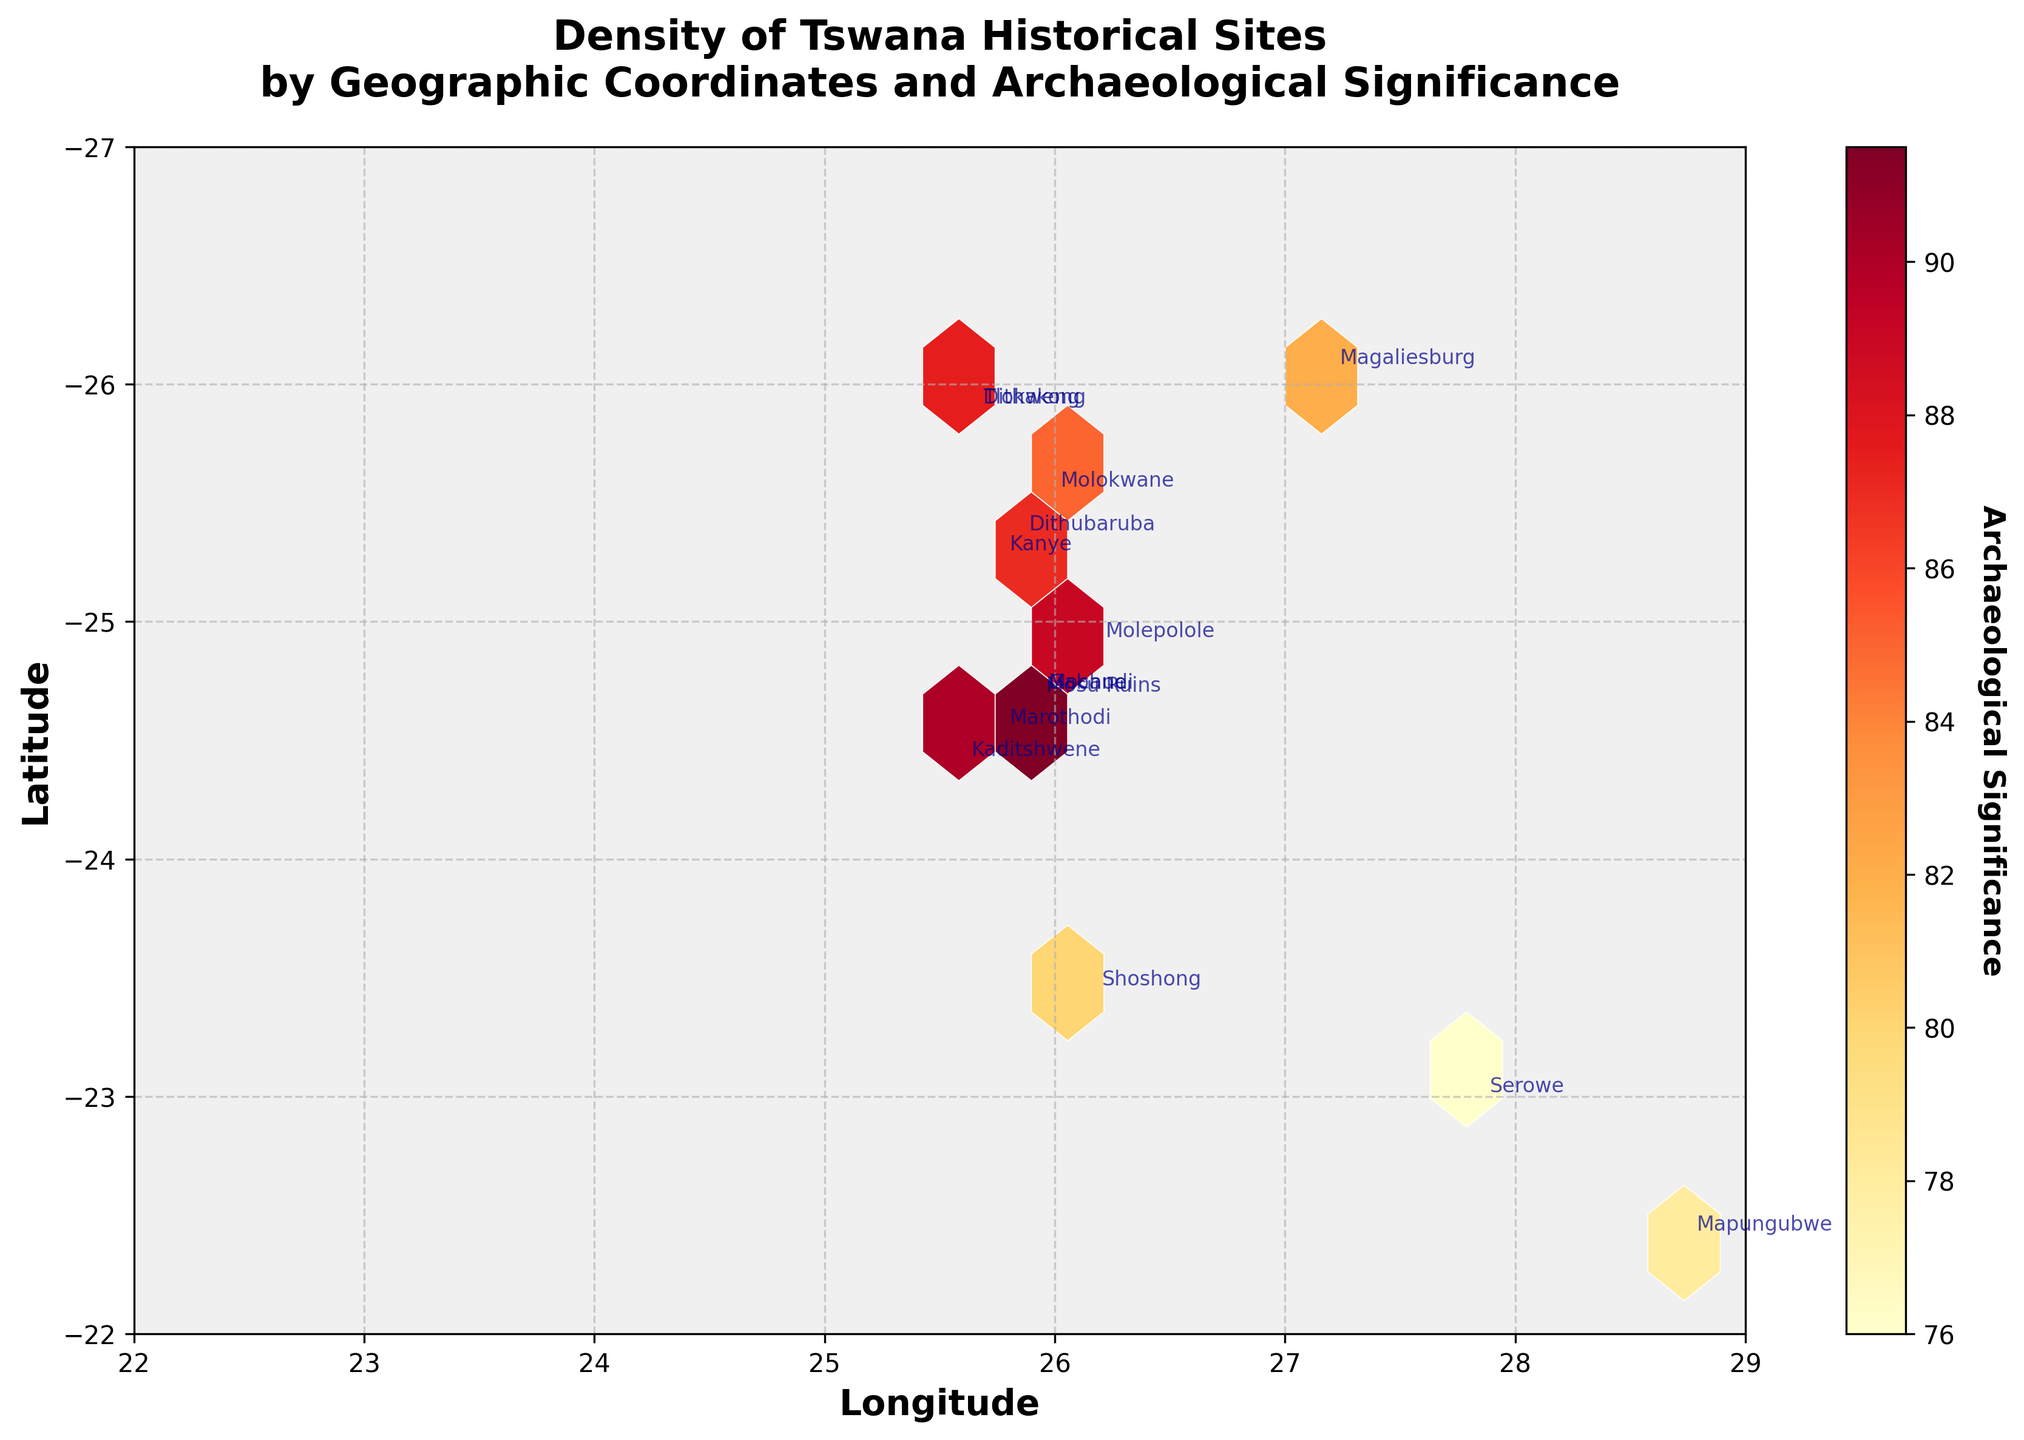Which site has the highest archaeological significance? The bar in the color legend or the specific annotations close to the hexagonal bins can help identify that Mosu Ruins has the highest archaeological significance with a value of 95.
Answer: Mosu Ruins What is the range of longitude covered by the sites? The x-axis of the hexbin plot displays the longitude range. The smallest longitude value is 22 and the largest is approximately 29.
Answer: 7 How densely clustered are the sites around latitude -24.6 and longitude 25.9? This can be seen by observing how many hexagons cluster near the coordinates (-24.6, 25.9). The density of sites in this area is high, indicated by dark color.
Answer: Very dense Which site is closest to the longitude of 25.7500? By looking at the hexagons and annotations around longitude 25.7500, we can find Marothodi and Kanye. The dot for Marothodi is more closely aligned with the specified longitude.
Answer: Marothodi Are sites more densely clustered around a particular latitude? The figure shows that there is a higher density of sites clustered around latitude -24.7 to -25 due to the higher intensity of colored hexagons around this latitude range.
Answer: Around -24.7 to -25 Which site is located furthest south? Observing the placement of site names in the hexbin plot, we can see that Magaliesburg is the furthest south.
Answer: Magaliesburg What is the median archaeological significance of the sites? First, list out the archaeological significance values: [76, 78, 80, 82, 83, 85, 86, 87, 88, 89, 90, 91, 92, 93, 95]. Since there are 15 sites, the median is the 8th value in this ordered list, which is 86.
Answer: 86 How does the significance of Marothodi compare to that of Tlokweng? By looking at their annotated values, Marothodi has an archaeological significance of 92, and Tlokweng has 87. Marothodi's archaeological significance is higher.
Answer: Marothodi is higher Which sites are located very close to each other geographically? By observing densely packed hexagons and site name annotations in close proximity, Gabane and Mochudi at latitude around -24.6667 and longitude 25.9167 are very close to each other.
Answer: Gabane and Mochudi 